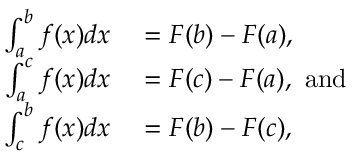Convert formula to latex. <formula><loc_0><loc_0><loc_500><loc_500>\begin{array} { r l } { \int _ { a } ^ { b } f ( x ) d x } & = F ( b ) - F ( a ) , } \\ { \int _ { a } ^ { c } f ( x ) d x } & = F ( c ) - F ( a ) , { a n d } } \\ { \int _ { c } ^ { b } f ( x ) d x } & = F ( b ) - F ( c ) , } \end{array}</formula> 